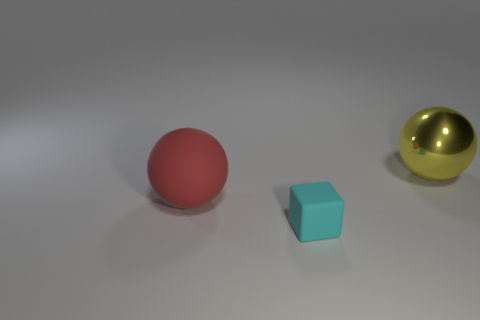Add 1 large red things. How many objects exist? 4 Subtract all yellow spheres. How many spheres are left? 1 Subtract all blocks. How many objects are left? 2 Subtract 2 spheres. How many spheres are left? 0 Subtract all gray blocks. Subtract all yellow cylinders. How many blocks are left? 1 Subtract all red rubber balls. Subtract all cyan matte objects. How many objects are left? 1 Add 2 spheres. How many spheres are left? 4 Add 2 big brown matte blocks. How many big brown matte blocks exist? 2 Subtract 0 gray cubes. How many objects are left? 3 